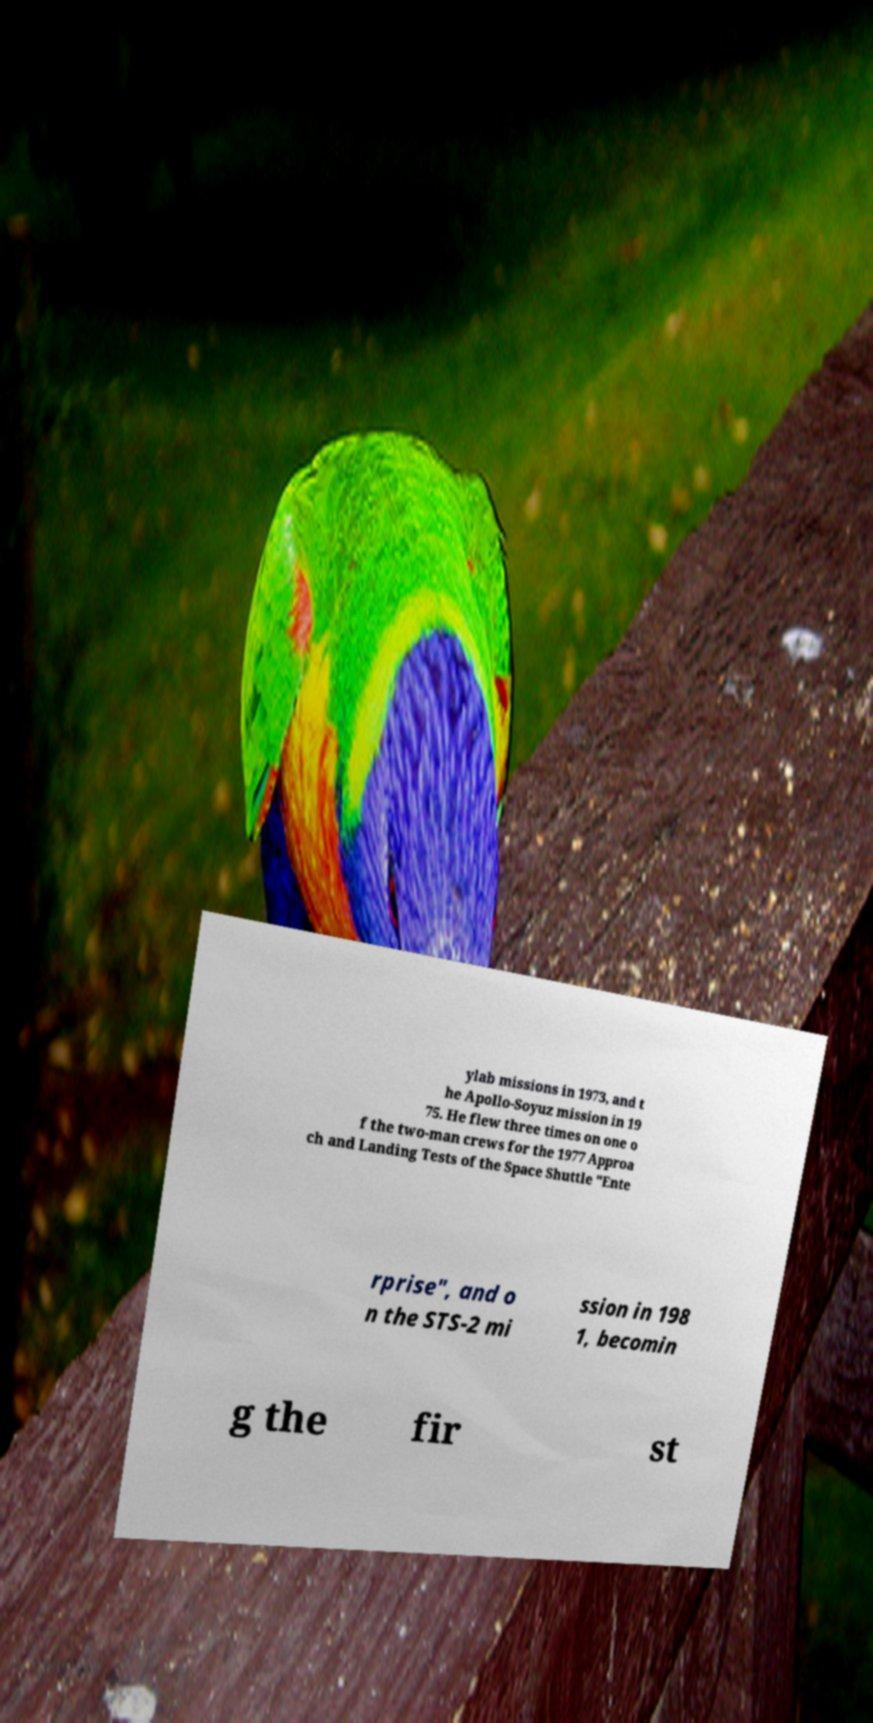Could you assist in decoding the text presented in this image and type it out clearly? ylab missions in 1973, and t he Apollo-Soyuz mission in 19 75. He flew three times on one o f the two-man crews for the 1977 Approa ch and Landing Tests of the Space Shuttle "Ente rprise", and o n the STS-2 mi ssion in 198 1, becomin g the fir st 